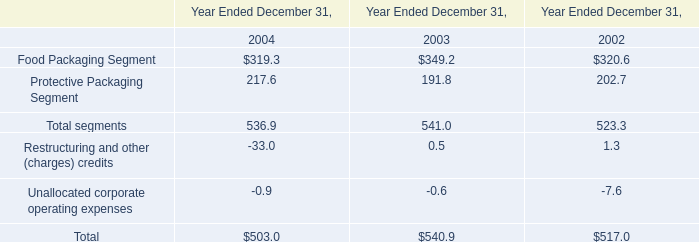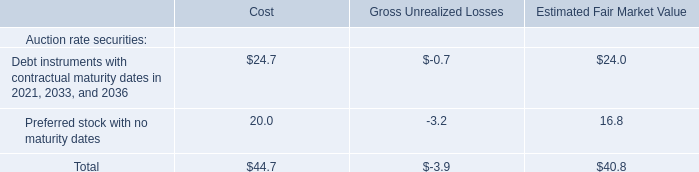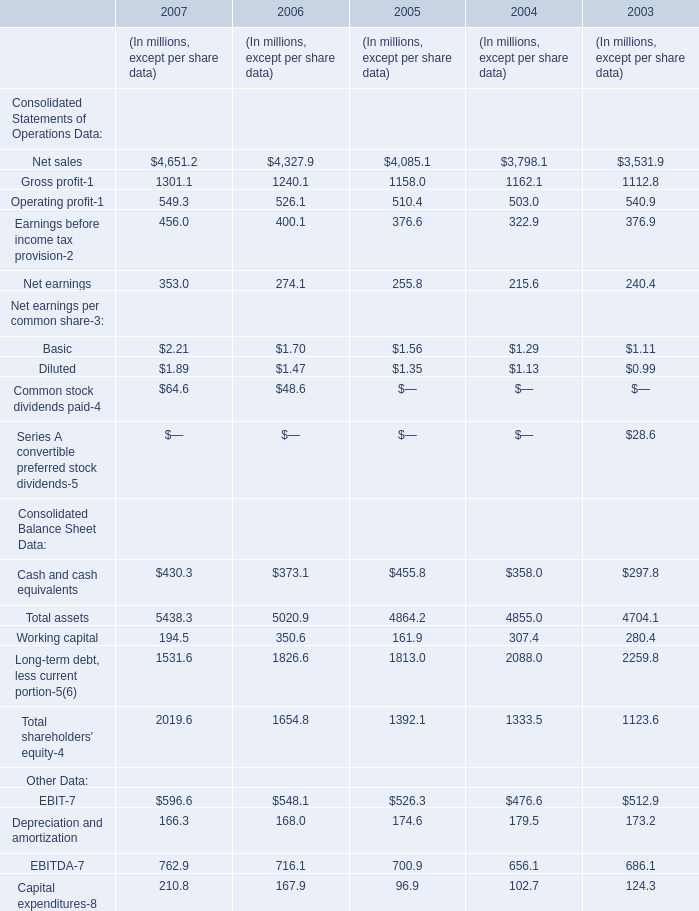As As the chart 2 shows,how much is the value of the Total assets for 2007 higher than the value of the Working capital for 2007? (in million) 
Computations: (5438.3 - 194.5)
Answer: 5243.8. 